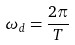<formula> <loc_0><loc_0><loc_500><loc_500>\omega _ { d } = \frac { 2 \pi } { T }</formula> 